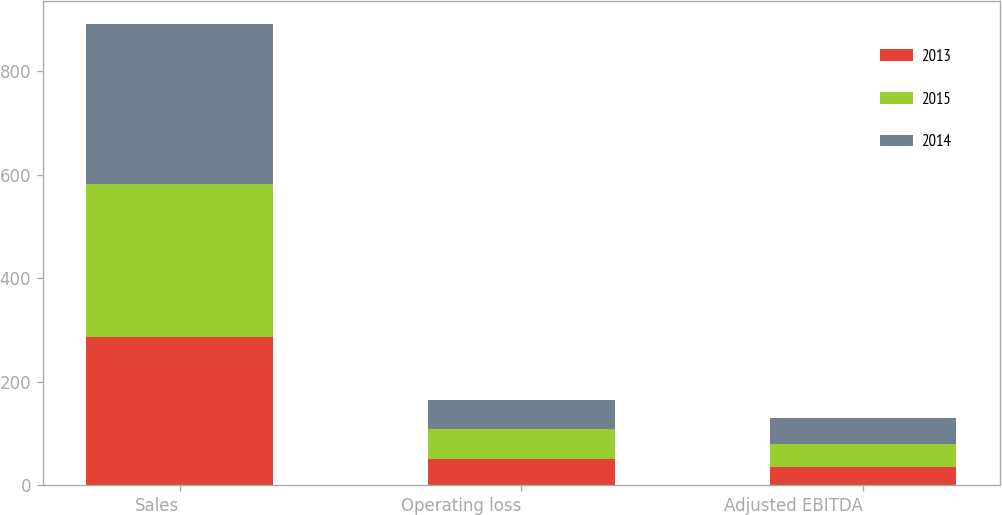Convert chart to OTSL. <chart><loc_0><loc_0><loc_500><loc_500><stacked_bar_chart><ecel><fcel>Sales<fcel>Operating loss<fcel>Adjusted EBITDA<nl><fcel>2013<fcel>286.8<fcel>51.6<fcel>35.9<nl><fcel>2015<fcel>296<fcel>57.3<fcel>44.4<nl><fcel>2014<fcel>309<fcel>56.5<fcel>49.6<nl></chart> 